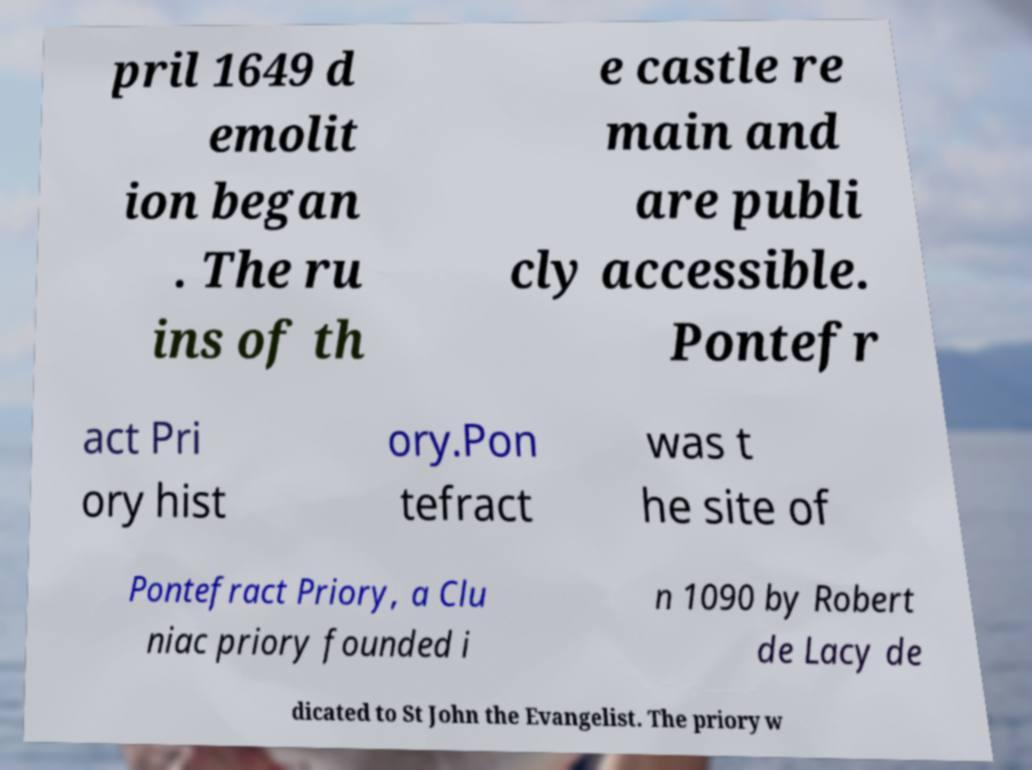There's text embedded in this image that I need extracted. Can you transcribe it verbatim? pril 1649 d emolit ion began . The ru ins of th e castle re main and are publi cly accessible. Pontefr act Pri ory hist ory.Pon tefract was t he site of Pontefract Priory, a Clu niac priory founded i n 1090 by Robert de Lacy de dicated to St John the Evangelist. The priory w 